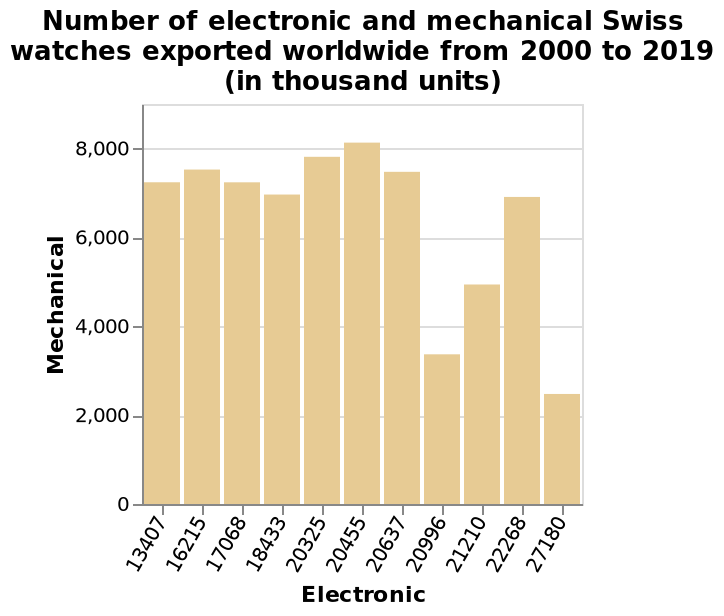<image>
please describe the details of the chart Number of electronic and mechanical Swiss watches exported worldwide from 2000 to 2019 (in thousand units) is a bar chart. On the x-axis, Electronic is shown as a scale from 13407 to 27180. There is a linear scale from 0 to 8,000 on the y-axis, labeled Mechanical. Is there a trend in the number of watches exported over the years? Yes, there is a gradual decline in the number of watches exported over the years. What is the average number of mechanical watches exported? The average number of mechanical watches exported is around 6,000. 